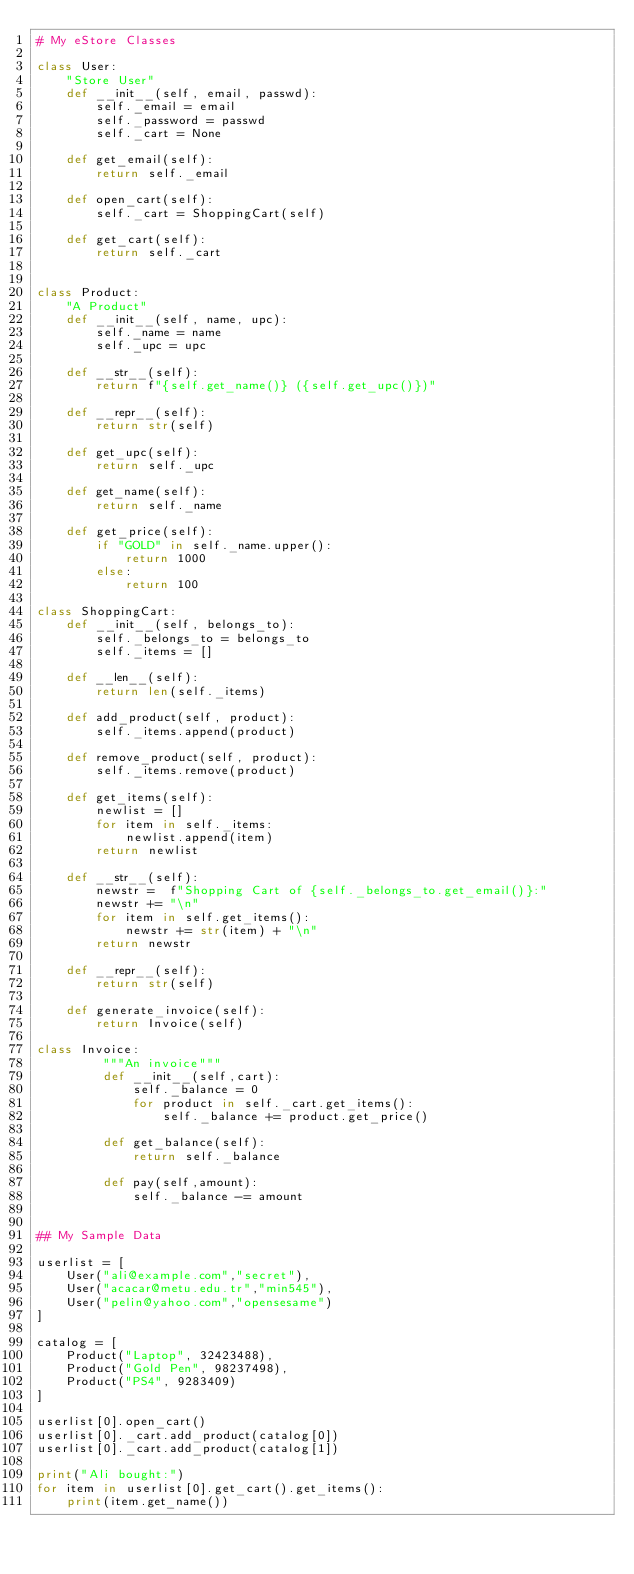Convert code to text. <code><loc_0><loc_0><loc_500><loc_500><_Python_># My eStore Classes

class User:
    "Store User"
    def __init__(self, email, passwd):
        self._email = email
        self._password = passwd
        self._cart = None

    def get_email(self):
        return self._email

    def open_cart(self):
        self._cart = ShoppingCart(self)

    def get_cart(self):
        return self._cart


class Product:
    "A Product"
    def __init__(self, name, upc):
        self._name = name
        self._upc = upc

    def __str__(self):
        return f"{self.get_name()} ({self.get_upc()})"

    def __repr__(self):
        return str(self)
    
    def get_upc(self):
        return self._upc

    def get_name(self):
        return self._name

    def get_price(self):
        if "GOLD" in self._name.upper():
            return 1000
        else:
            return 100

class ShoppingCart:
    def __init__(self, belongs_to):
        self._belongs_to = belongs_to
        self._items = []

    def __len__(self):
        return len(self._items)
    
    def add_product(self, product):
        self._items.append(product)

    def remove_product(self, product):
        self._items.remove(product)

    def get_items(self):
        newlist = []
        for item in self._items:
            newlist.append(item)
        return newlist

    def __str__(self):
        newstr =  f"Shopping Cart of {self._belongs_to.get_email()}:"
        newstr += "\n"
        for item in self.get_items():
            newstr += str(item) + "\n"
        return newstr
    
    def __repr__(self):
        return str(self)

    def generate_invoice(self):
        return Invoice(self)

class Invoice:
         """An invoice"""
         def __init__(self,cart):
             self._balance = 0
             for product in self._cart.get_items():
                 self._balance += product.get_price()

         def get_balance(self):
             return self._balance

         def pay(self,amount):
             self._balance -= amount

             
## My Sample Data

userlist = [
    User("ali@example.com","secret"),
    User("acacar@metu.edu.tr","min545"),
    User("pelin@yahoo.com","opensesame")
]
        
catalog = [
    Product("Laptop", 32423488),
    Product("Gold Pen", 98237498),
    Product("PS4", 9283409)
]
    
userlist[0].open_cart()
userlist[0]._cart.add_product(catalog[0])
userlist[0]._cart.add_product(catalog[1])

print("Ali bought:")
for item in userlist[0].get_cart().get_items():
    print(item.get_name())
</code> 